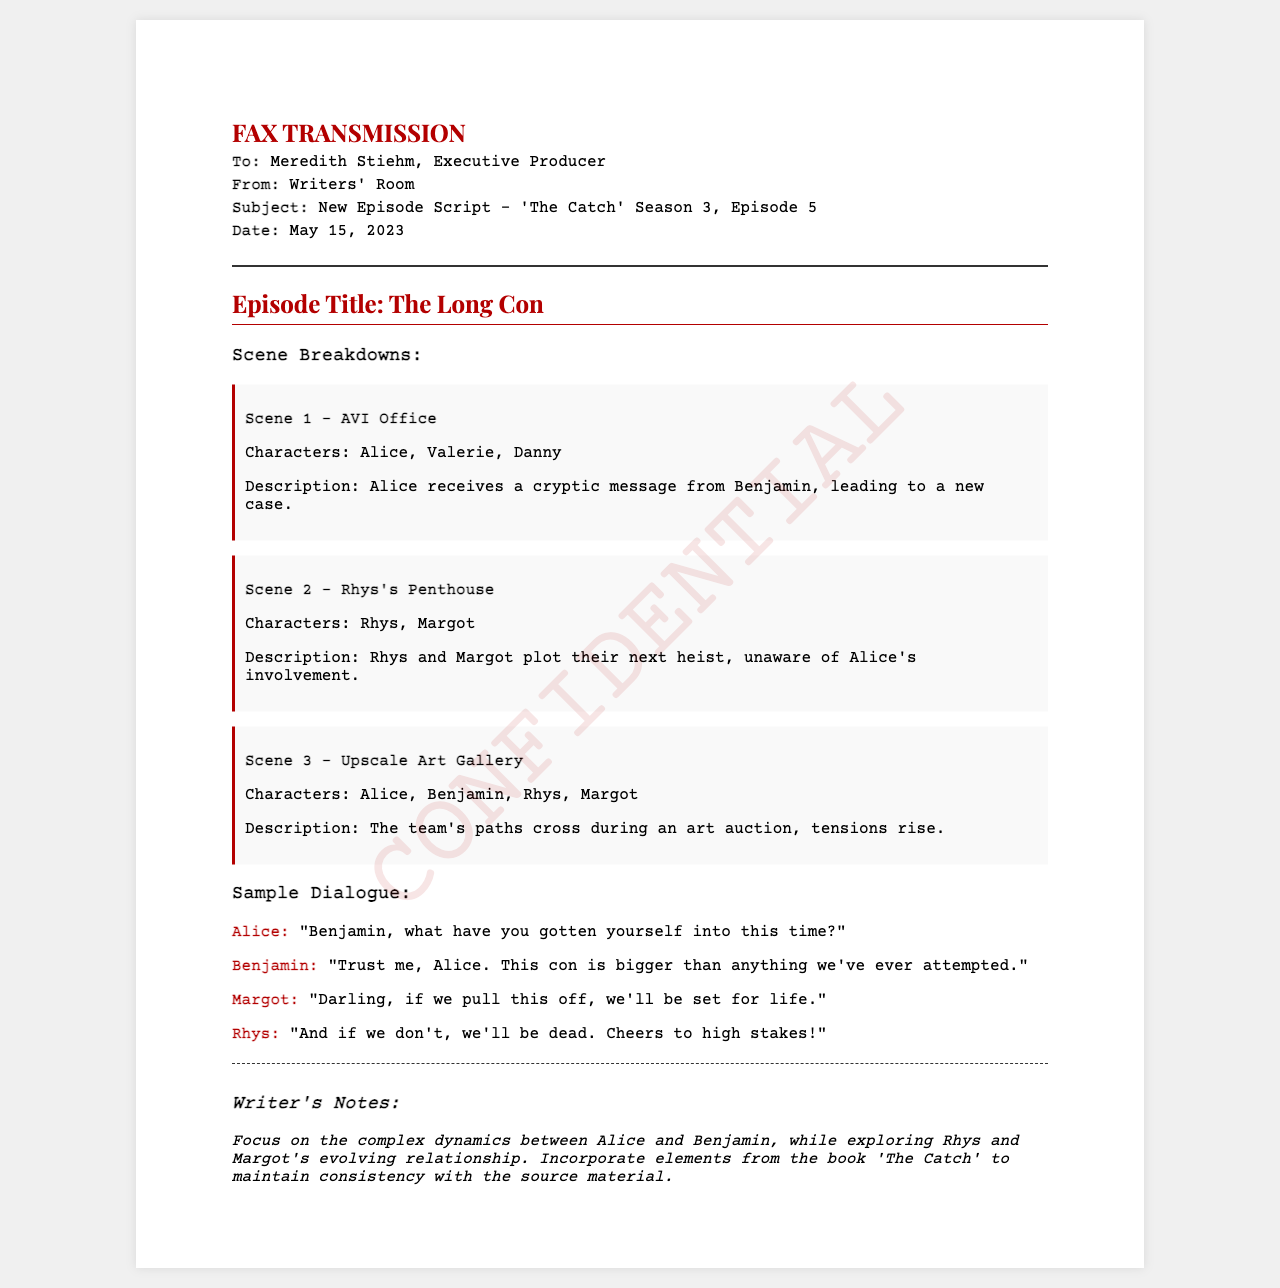What is the episode title? The episode title is listed in the document as part of the fax content.
Answer: The Long Con Who is the executive producer? The executive producer's name is mentioned in the header of the fax.
Answer: Meredith Stiehm What is the date of the fax? The date is specified in the fax header, indicating when the document was sent.
Answer: May 15, 2023 How many scenes are outlined in the document? The document includes a section for scene breakdowns, listing the number of scenes.
Answer: Three Which character says, "Trust me, Alice. This con is bigger than anything we've ever attempted."? The dialogue section identifies who speaks each line.
Answer: Benjamin What is the primary focus mentioned in the writer's notes? The writer's notes summarize the thematic focus for this episode that should be maintained throughout.
Answer: Complex dynamics between Alice and Benjamin What location is Scene 1 set in? Each scene description indicates where the action takes place.
Answer: AVI Office Which two characters plot their next heist in Scene 2? The character list in Scene 2 identifies who is involved in the plot.
Answer: Rhys, Margot What is the central conflict indicated in Scene 3? The description of Scene 3 hints at the tension that arises during a interaction among characters.
Answer: Tensions rise during an art auction 